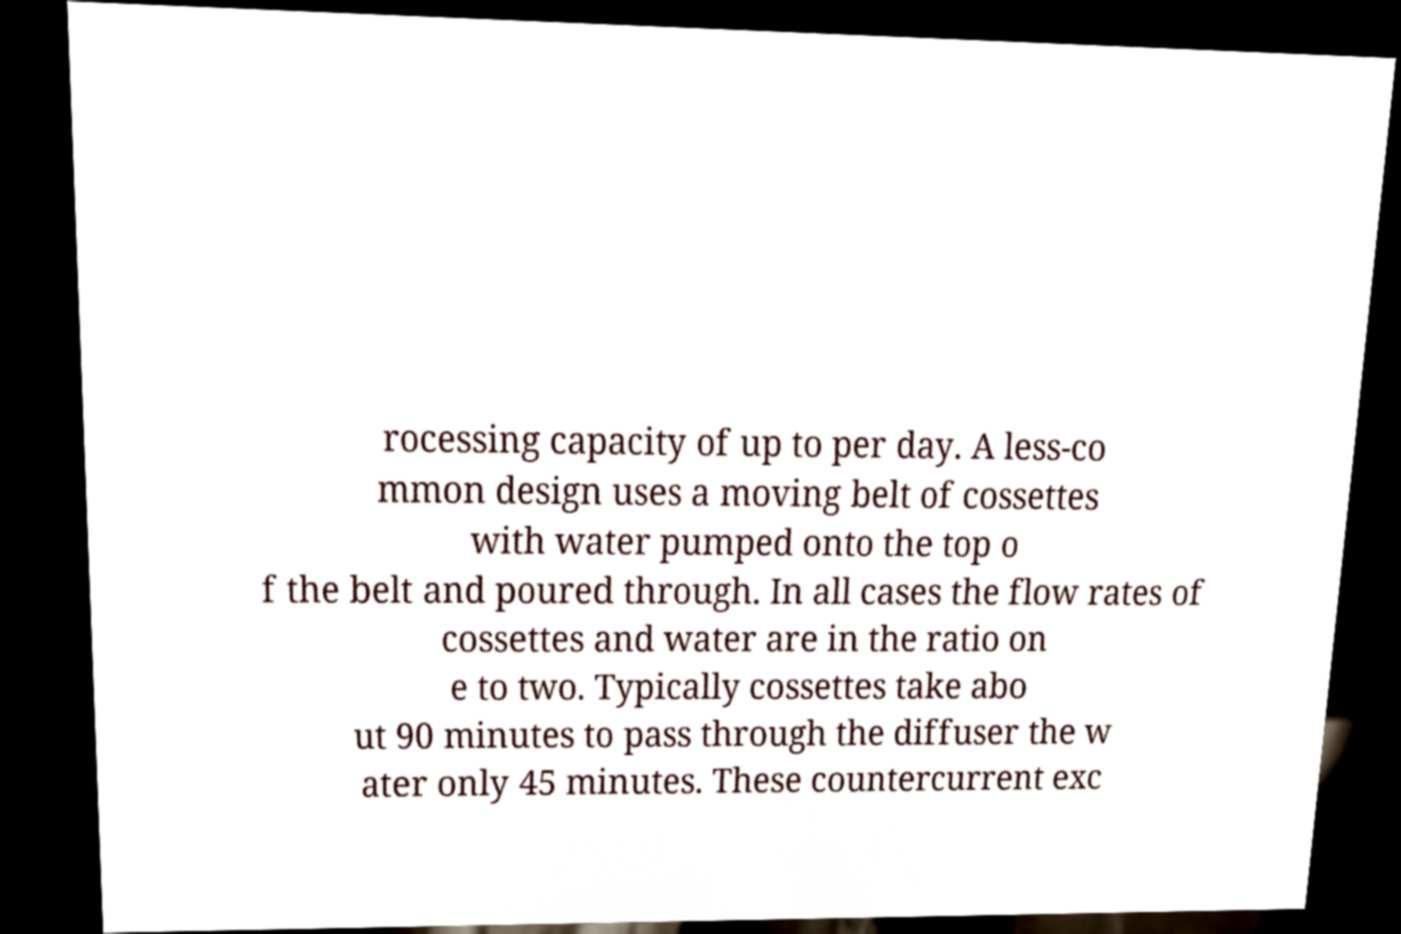Could you assist in decoding the text presented in this image and type it out clearly? rocessing capacity of up to per day. A less-co mmon design uses a moving belt of cossettes with water pumped onto the top o f the belt and poured through. In all cases the flow rates of cossettes and water are in the ratio on e to two. Typically cossettes take abo ut 90 minutes to pass through the diffuser the w ater only 45 minutes. These countercurrent exc 